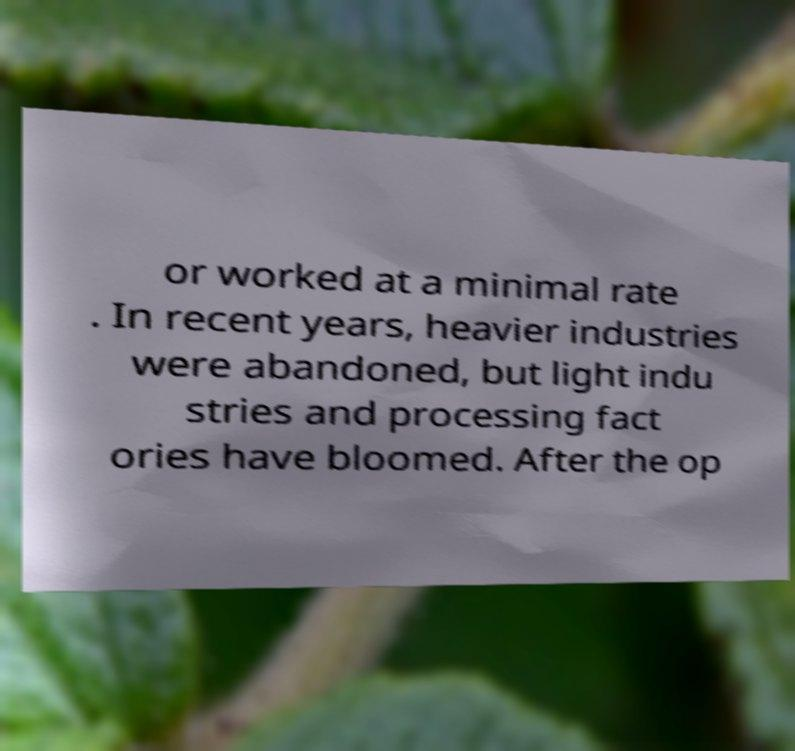What messages or text are displayed in this image? I need them in a readable, typed format. or worked at a minimal rate . In recent years, heavier industries were abandoned, but light indu stries and processing fact ories have bloomed. After the op 